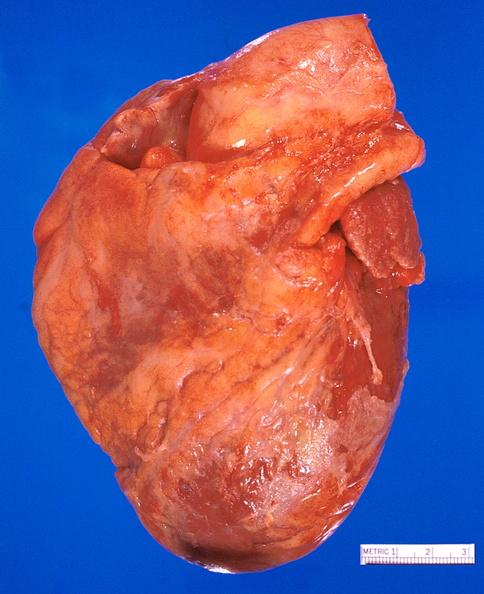where is this?
Answer the question using a single word or phrase. Heart 